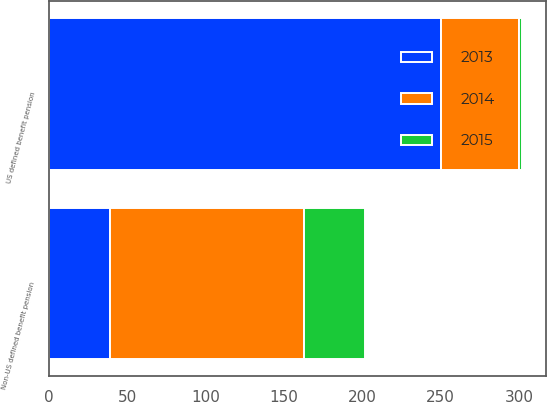Convert chart. <chart><loc_0><loc_0><loc_500><loc_500><stacked_bar_chart><ecel><fcel>US defined benefit pension<fcel>Non-US defined benefit pension<nl><fcel>2013<fcel>250<fcel>39<nl><fcel>2015<fcel>2<fcel>39<nl><fcel>2014<fcel>50<fcel>124<nl></chart> 